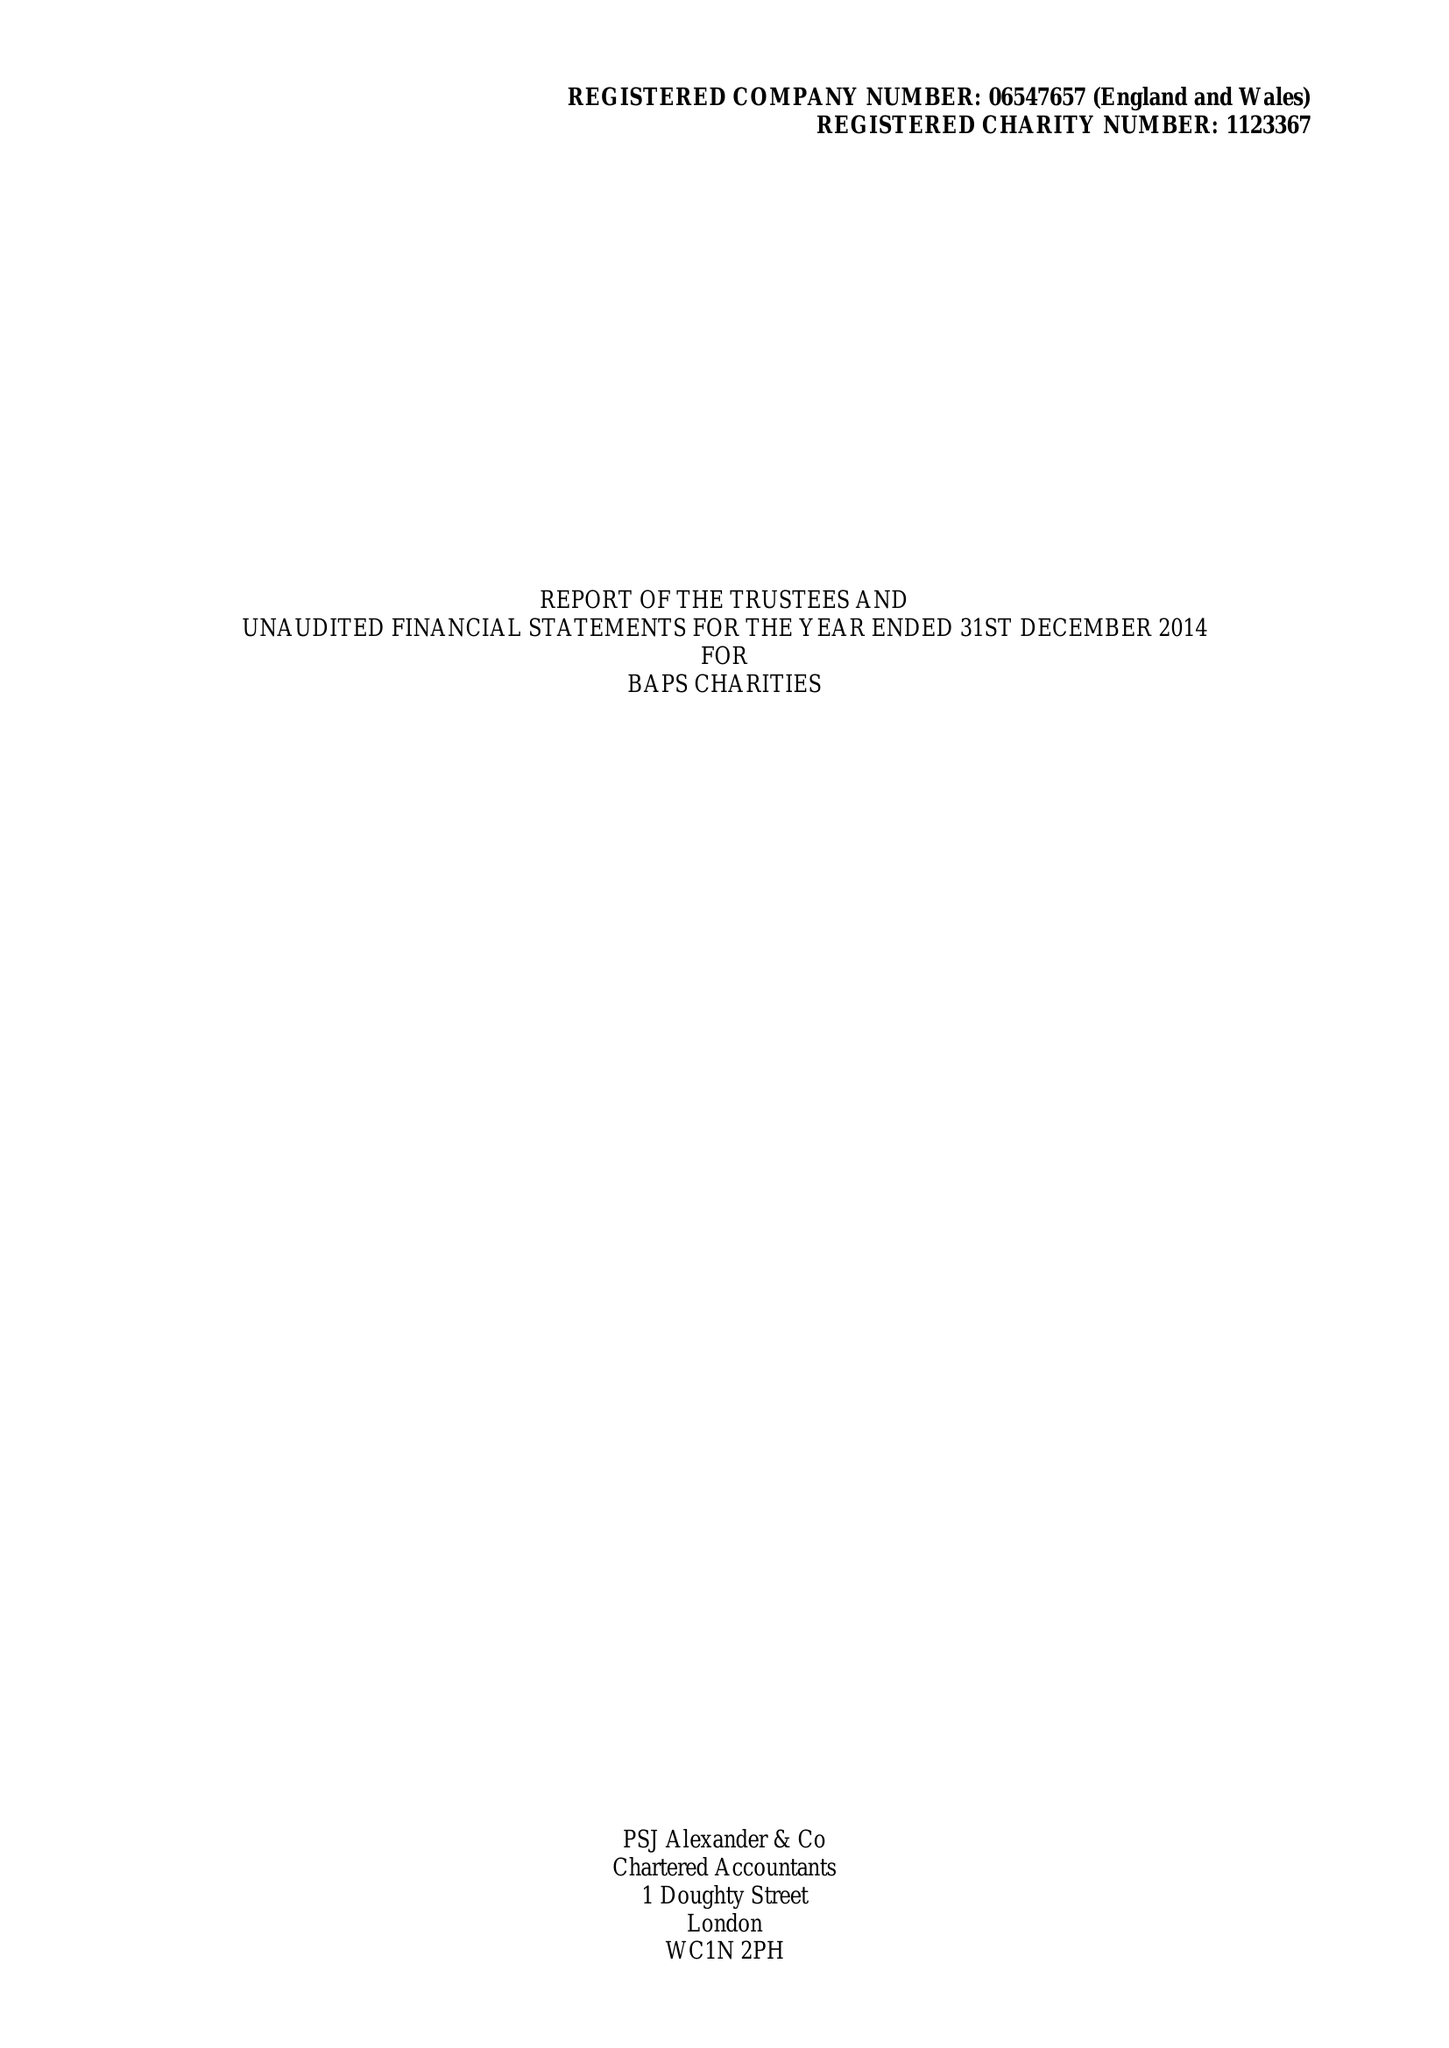What is the value for the charity_name?
Answer the question using a single word or phrase. Baps Charities 